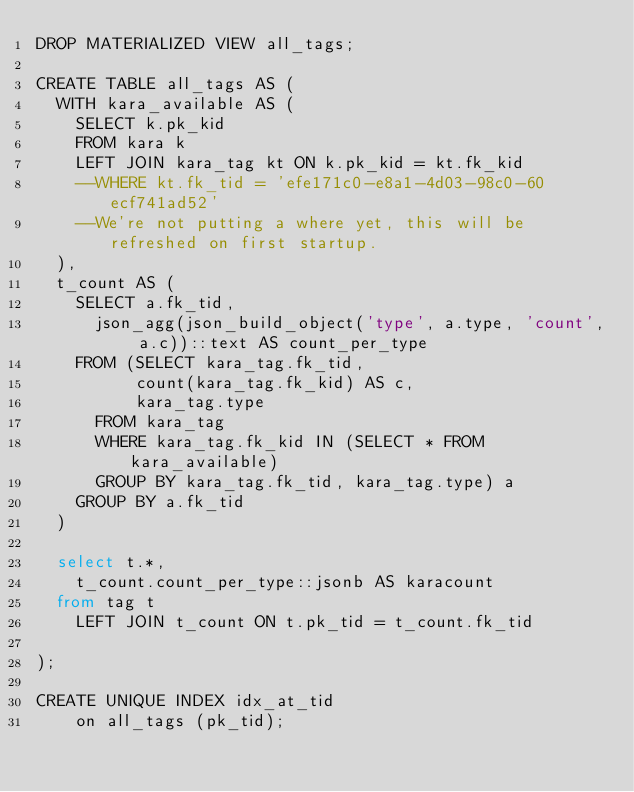Convert code to text. <code><loc_0><loc_0><loc_500><loc_500><_SQL_>DROP MATERIALIZED VIEW all_tags;

CREATE TABLE all_tags AS (
	WITH kara_available AS (
		SELECT k.pk_kid
		FROM kara k
		LEFT JOIN kara_tag kt ON k.pk_kid = kt.fk_kid
		--WHERE kt.fk_tid = 'efe171c0-e8a1-4d03-98c0-60ecf741ad52' 
		--We're not putting a where yet, this will be refreshed on first startup.
	), 
	t_count AS (
		SELECT a.fk_tid,
			json_agg(json_build_object('type', a.type, 'count', a.c))::text AS count_per_type
		FROM (SELECT kara_tag.fk_tid,
					count(kara_tag.fk_kid) AS c,
					kara_tag.type
			FROM kara_tag
			WHERE kara_tag.fk_kid IN (SELECT * FROM kara_available)
			GROUP BY kara_tag.fk_tid, kara_tag.type) a
		GROUP BY a.fk_tid
	)

	select t.*,
		t_count.count_per_type::jsonb AS karacount
	from tag t
		LEFT JOIN t_count ON t.pk_tid = t_count.fk_tid

);

CREATE UNIQUE INDEX idx_at_tid
    on all_tags (pk_tid);
</code> 